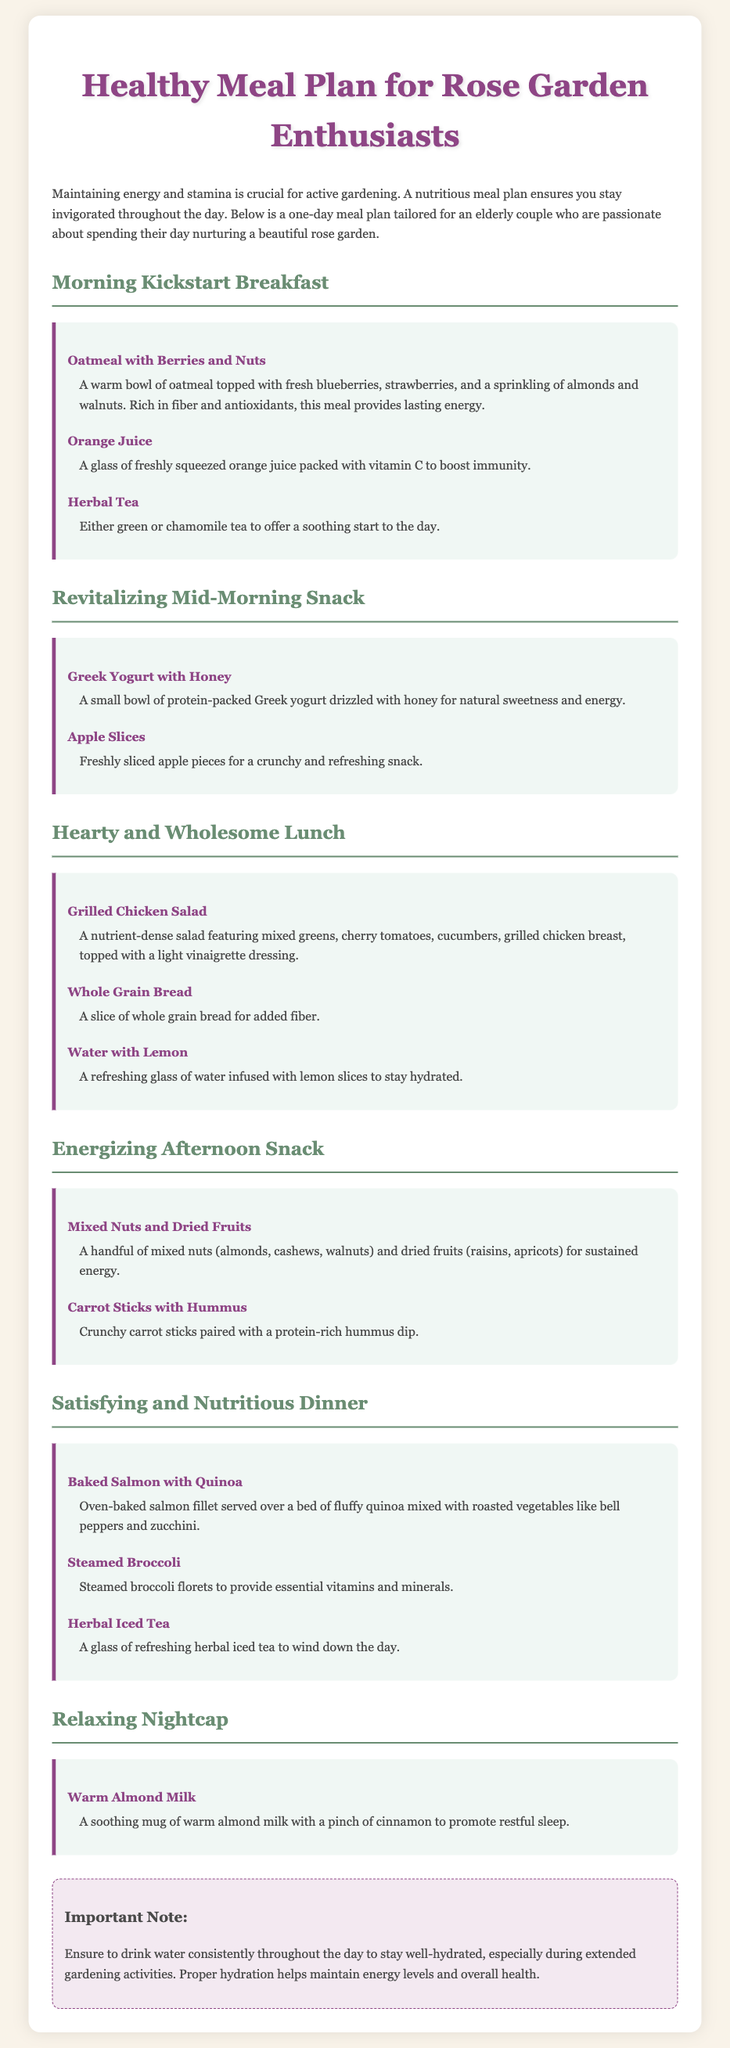What is the title of the meal plan? The title of the meal plan is stated at the top of the document.
Answer: Healthy Meal Plan for Rose Garden Enthusiasts What meal is suggested for breakfast? The meal suggested for breakfast is listed in the section for the morning meal.
Answer: Oatmeal with Berries and Nuts Which drink is paired with lunch? The drink mentioned alongside lunch is described in that meal section.
Answer: Water with Lemon What is a healthy option for an afternoon snack? The afternoon snack options are detailed in the corresponding meal section.
Answer: Mixed Nuts and Dried Fruits How many main meals are included in the plan? The number of main meals can be counted from the distinct meal sections outlined in the document.
Answer: Five Which type of tea is recommended for breakfast? The type of tea mentioned at breakfast can be found in the breakfast meal section.
Answer: Herbal Tea What does the nightcap consist of? The nightcap information is provided at the end of the document within the relevant section.
Answer: Warm Almond Milk What is an important note regarding hydration? The important note is specified in a distinct section towards the end of the document.
Answer: Drink water consistently throughout the day What kind of fish is included in the dinner meal? The type of fish included in the dinner meal can be identified in the dinner section of the meal plan.
Answer: Salmon 